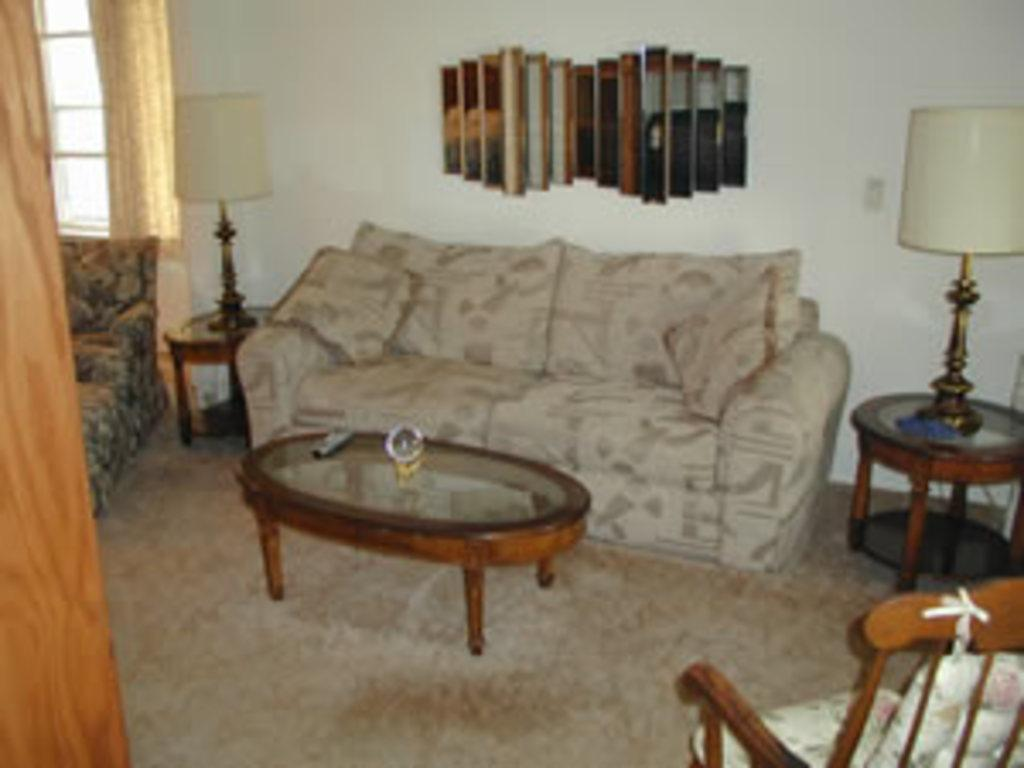What piece of furniture is located in the middle of the image? There is a sofa in the middle of the image. What is placed on either side of the sofa? There are lamps on either side of the sofa. What can be seen on the left side of the image? There is a window on the left side of the image. What other piece of furniture is visible in the image? There is a chair on the right side of the image. How far away is the dirt visible from the sofa in the image? There is no dirt visible in the image, as it features a sofa, lamps, a window, and a chair. 